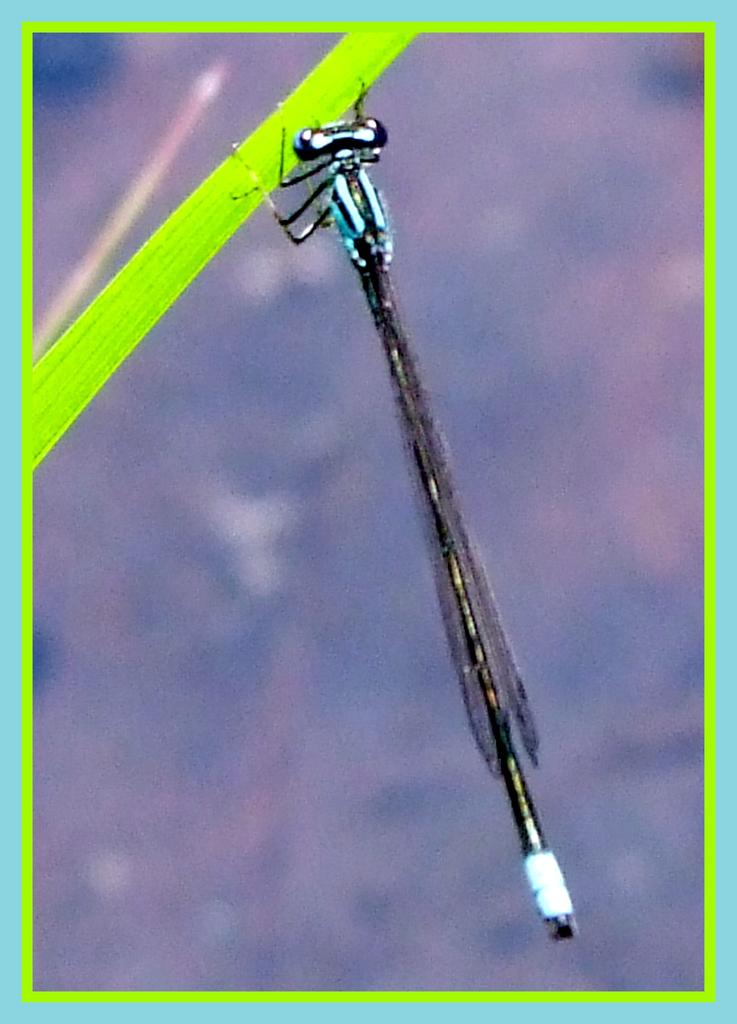What colors are used for the borders in the image? The image has blue and green borders. What can be seen on the leaf in the image? There is an insect on a leaf in the image. How would you describe the background of the image? The background of the image is blurred. What type of music is the insect playing on the ship in the image? There is no music, insect playing music, or ship present in the image. 